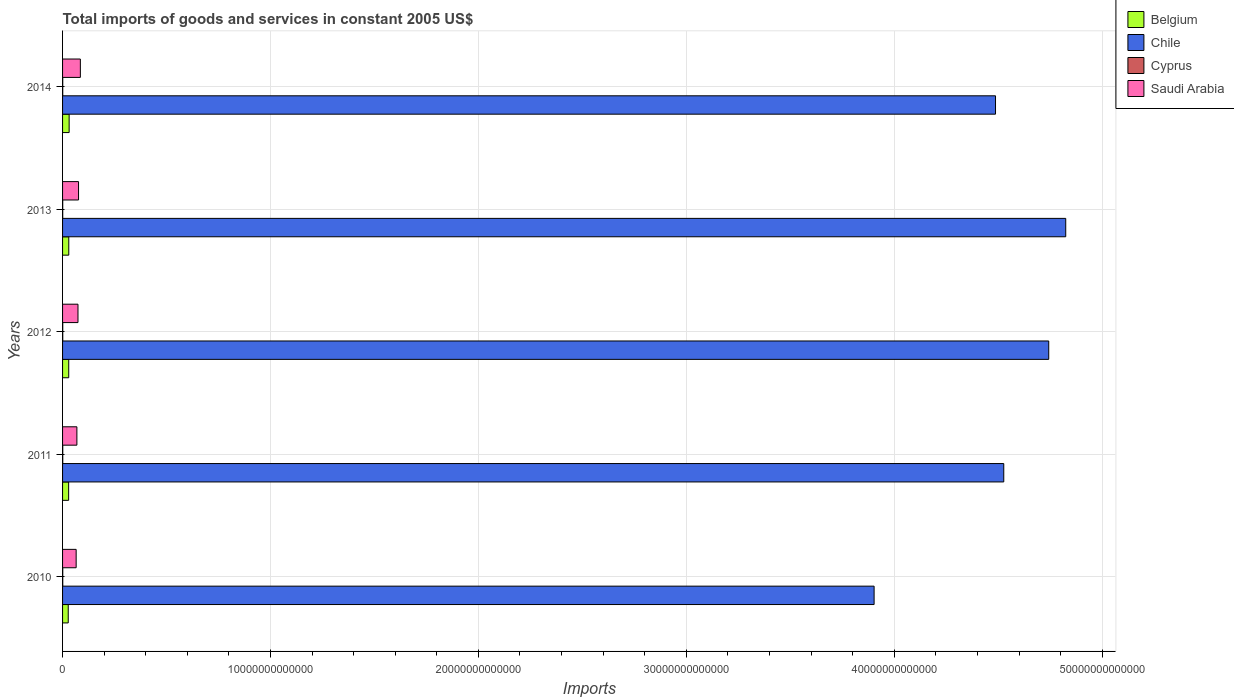How many groups of bars are there?
Make the answer very short. 5. Are the number of bars on each tick of the Y-axis equal?
Your answer should be compact. Yes. How many bars are there on the 5th tick from the bottom?
Make the answer very short. 4. What is the total imports of goods and services in Cyprus in 2012?
Ensure brevity in your answer.  8.72e+09. Across all years, what is the maximum total imports of goods and services in Cyprus?
Ensure brevity in your answer.  9.20e+09. Across all years, what is the minimum total imports of goods and services in Chile?
Keep it short and to the point. 3.90e+13. In which year was the total imports of goods and services in Saudi Arabia minimum?
Keep it short and to the point. 2010. What is the total total imports of goods and services in Saudi Arabia in the graph?
Your answer should be very brief. 3.71e+12. What is the difference between the total imports of goods and services in Cyprus in 2010 and that in 2014?
Offer a terse response. 1.06e+09. What is the difference between the total imports of goods and services in Chile in 2011 and the total imports of goods and services in Belgium in 2013?
Offer a terse response. 4.50e+13. What is the average total imports of goods and services in Saudi Arabia per year?
Offer a very short reply. 7.42e+11. In the year 2011, what is the difference between the total imports of goods and services in Cyprus and total imports of goods and services in Belgium?
Provide a succinct answer. -2.83e+11. What is the ratio of the total imports of goods and services in Belgium in 2011 to that in 2014?
Keep it short and to the point. 0.92. Is the total imports of goods and services in Chile in 2013 less than that in 2014?
Your response must be concise. No. Is the difference between the total imports of goods and services in Cyprus in 2011 and 2013 greater than the difference between the total imports of goods and services in Belgium in 2011 and 2013?
Provide a succinct answer. Yes. What is the difference between the highest and the second highest total imports of goods and services in Cyprus?
Offer a very short reply. 5.69e+07. What is the difference between the highest and the lowest total imports of goods and services in Belgium?
Offer a very short reply. 4.38e+1. Is the sum of the total imports of goods and services in Chile in 2011 and 2012 greater than the maximum total imports of goods and services in Cyprus across all years?
Provide a short and direct response. Yes. Is it the case that in every year, the sum of the total imports of goods and services in Cyprus and total imports of goods and services in Chile is greater than the sum of total imports of goods and services in Belgium and total imports of goods and services in Saudi Arabia?
Keep it short and to the point. Yes. Is it the case that in every year, the sum of the total imports of goods and services in Belgium and total imports of goods and services in Chile is greater than the total imports of goods and services in Cyprus?
Your response must be concise. Yes. How many bars are there?
Provide a short and direct response. 20. What is the difference between two consecutive major ticks on the X-axis?
Your answer should be very brief. 1.00e+13. Are the values on the major ticks of X-axis written in scientific E-notation?
Make the answer very short. No. Does the graph contain any zero values?
Ensure brevity in your answer.  No. Does the graph contain grids?
Offer a very short reply. Yes. What is the title of the graph?
Make the answer very short. Total imports of goods and services in constant 2005 US$. What is the label or title of the X-axis?
Keep it short and to the point. Imports. What is the Imports of Belgium in 2010?
Provide a succinct answer. 2.73e+11. What is the Imports of Chile in 2010?
Your answer should be compact. 3.90e+13. What is the Imports of Cyprus in 2010?
Your response must be concise. 9.20e+09. What is the Imports in Saudi Arabia in 2010?
Ensure brevity in your answer.  6.53e+11. What is the Imports of Belgium in 2011?
Make the answer very short. 2.92e+11. What is the Imports of Chile in 2011?
Your answer should be compact. 4.53e+13. What is the Imports in Cyprus in 2011?
Your answer should be very brief. 9.14e+09. What is the Imports in Saudi Arabia in 2011?
Keep it short and to the point. 6.89e+11. What is the Imports of Belgium in 2012?
Ensure brevity in your answer.  2.97e+11. What is the Imports of Chile in 2012?
Offer a terse response. 4.74e+13. What is the Imports in Cyprus in 2012?
Make the answer very short. 8.72e+09. What is the Imports of Saudi Arabia in 2012?
Your response must be concise. 7.42e+11. What is the Imports of Belgium in 2013?
Provide a succinct answer. 2.99e+11. What is the Imports in Chile in 2013?
Your answer should be compact. 4.82e+13. What is the Imports in Cyprus in 2013?
Your answer should be very brief. 7.54e+09. What is the Imports in Saudi Arabia in 2013?
Your response must be concise. 7.69e+11. What is the Imports of Belgium in 2014?
Your answer should be compact. 3.16e+11. What is the Imports of Chile in 2014?
Provide a short and direct response. 4.49e+13. What is the Imports of Cyprus in 2014?
Offer a terse response. 8.14e+09. What is the Imports of Saudi Arabia in 2014?
Ensure brevity in your answer.  8.56e+11. Across all years, what is the maximum Imports of Belgium?
Provide a succinct answer. 3.16e+11. Across all years, what is the maximum Imports of Chile?
Provide a succinct answer. 4.82e+13. Across all years, what is the maximum Imports of Cyprus?
Your answer should be compact. 9.20e+09. Across all years, what is the maximum Imports in Saudi Arabia?
Make the answer very short. 8.56e+11. Across all years, what is the minimum Imports of Belgium?
Keep it short and to the point. 2.73e+11. Across all years, what is the minimum Imports in Chile?
Your answer should be very brief. 3.90e+13. Across all years, what is the minimum Imports in Cyprus?
Ensure brevity in your answer.  7.54e+09. Across all years, what is the minimum Imports of Saudi Arabia?
Your answer should be compact. 6.53e+11. What is the total Imports in Belgium in the graph?
Offer a very short reply. 1.48e+12. What is the total Imports in Chile in the graph?
Your answer should be compact. 2.25e+14. What is the total Imports of Cyprus in the graph?
Offer a very short reply. 4.27e+1. What is the total Imports of Saudi Arabia in the graph?
Offer a terse response. 3.71e+12. What is the difference between the Imports in Belgium in 2010 and that in 2011?
Make the answer very short. -1.99e+1. What is the difference between the Imports in Chile in 2010 and that in 2011?
Your response must be concise. -6.24e+12. What is the difference between the Imports of Cyprus in 2010 and that in 2011?
Your response must be concise. 5.69e+07. What is the difference between the Imports in Saudi Arabia in 2010 and that in 2011?
Keep it short and to the point. -3.57e+1. What is the difference between the Imports of Belgium in 2010 and that in 2012?
Give a very brief answer. -2.40e+1. What is the difference between the Imports in Chile in 2010 and that in 2012?
Keep it short and to the point. -8.40e+12. What is the difference between the Imports in Cyprus in 2010 and that in 2012?
Provide a succinct answer. 4.77e+08. What is the difference between the Imports of Saudi Arabia in 2010 and that in 2012?
Provide a short and direct response. -8.85e+1. What is the difference between the Imports of Belgium in 2010 and that in 2013?
Your answer should be compact. -2.62e+1. What is the difference between the Imports of Chile in 2010 and that in 2013?
Keep it short and to the point. -9.22e+12. What is the difference between the Imports of Cyprus in 2010 and that in 2013?
Your answer should be very brief. 1.66e+09. What is the difference between the Imports in Saudi Arabia in 2010 and that in 2013?
Provide a succinct answer. -1.16e+11. What is the difference between the Imports in Belgium in 2010 and that in 2014?
Keep it short and to the point. -4.38e+1. What is the difference between the Imports of Chile in 2010 and that in 2014?
Provide a short and direct response. -5.84e+12. What is the difference between the Imports of Cyprus in 2010 and that in 2014?
Keep it short and to the point. 1.06e+09. What is the difference between the Imports of Saudi Arabia in 2010 and that in 2014?
Your answer should be compact. -2.03e+11. What is the difference between the Imports of Belgium in 2011 and that in 2012?
Make the answer very short. -4.03e+09. What is the difference between the Imports in Chile in 2011 and that in 2012?
Keep it short and to the point. -2.16e+12. What is the difference between the Imports of Cyprus in 2011 and that in 2012?
Provide a succinct answer. 4.20e+08. What is the difference between the Imports of Saudi Arabia in 2011 and that in 2012?
Keep it short and to the point. -5.28e+1. What is the difference between the Imports in Belgium in 2011 and that in 2013?
Give a very brief answer. -6.32e+09. What is the difference between the Imports in Chile in 2011 and that in 2013?
Offer a very short reply. -2.98e+12. What is the difference between the Imports in Cyprus in 2011 and that in 2013?
Your response must be concise. 1.61e+09. What is the difference between the Imports in Saudi Arabia in 2011 and that in 2013?
Make the answer very short. -7.99e+1. What is the difference between the Imports of Belgium in 2011 and that in 2014?
Ensure brevity in your answer.  -2.39e+1. What is the difference between the Imports of Chile in 2011 and that in 2014?
Your response must be concise. 3.96e+11. What is the difference between the Imports in Cyprus in 2011 and that in 2014?
Offer a terse response. 9.99e+08. What is the difference between the Imports of Saudi Arabia in 2011 and that in 2014?
Offer a terse response. -1.67e+11. What is the difference between the Imports in Belgium in 2012 and that in 2013?
Give a very brief answer. -2.29e+09. What is the difference between the Imports in Chile in 2012 and that in 2013?
Make the answer very short. -8.18e+11. What is the difference between the Imports in Cyprus in 2012 and that in 2013?
Offer a very short reply. 1.19e+09. What is the difference between the Imports in Saudi Arabia in 2012 and that in 2013?
Keep it short and to the point. -2.71e+1. What is the difference between the Imports in Belgium in 2012 and that in 2014?
Make the answer very short. -1.99e+1. What is the difference between the Imports of Chile in 2012 and that in 2014?
Give a very brief answer. 2.56e+12. What is the difference between the Imports of Cyprus in 2012 and that in 2014?
Provide a succinct answer. 5.79e+08. What is the difference between the Imports of Saudi Arabia in 2012 and that in 2014?
Provide a short and direct response. -1.14e+11. What is the difference between the Imports in Belgium in 2013 and that in 2014?
Provide a succinct answer. -1.76e+1. What is the difference between the Imports of Chile in 2013 and that in 2014?
Give a very brief answer. 3.38e+12. What is the difference between the Imports of Cyprus in 2013 and that in 2014?
Provide a short and direct response. -6.08e+08. What is the difference between the Imports of Saudi Arabia in 2013 and that in 2014?
Offer a terse response. -8.70e+1. What is the difference between the Imports in Belgium in 2010 and the Imports in Chile in 2011?
Keep it short and to the point. -4.50e+13. What is the difference between the Imports in Belgium in 2010 and the Imports in Cyprus in 2011?
Offer a terse response. 2.63e+11. What is the difference between the Imports of Belgium in 2010 and the Imports of Saudi Arabia in 2011?
Offer a terse response. -4.16e+11. What is the difference between the Imports in Chile in 2010 and the Imports in Cyprus in 2011?
Provide a succinct answer. 3.90e+13. What is the difference between the Imports of Chile in 2010 and the Imports of Saudi Arabia in 2011?
Your answer should be compact. 3.83e+13. What is the difference between the Imports in Cyprus in 2010 and the Imports in Saudi Arabia in 2011?
Give a very brief answer. -6.80e+11. What is the difference between the Imports in Belgium in 2010 and the Imports in Chile in 2012?
Ensure brevity in your answer.  -4.72e+13. What is the difference between the Imports in Belgium in 2010 and the Imports in Cyprus in 2012?
Your answer should be compact. 2.64e+11. What is the difference between the Imports in Belgium in 2010 and the Imports in Saudi Arabia in 2012?
Your response must be concise. -4.69e+11. What is the difference between the Imports in Chile in 2010 and the Imports in Cyprus in 2012?
Your answer should be very brief. 3.90e+13. What is the difference between the Imports in Chile in 2010 and the Imports in Saudi Arabia in 2012?
Keep it short and to the point. 3.83e+13. What is the difference between the Imports in Cyprus in 2010 and the Imports in Saudi Arabia in 2012?
Provide a short and direct response. -7.33e+11. What is the difference between the Imports of Belgium in 2010 and the Imports of Chile in 2013?
Your answer should be very brief. -4.80e+13. What is the difference between the Imports in Belgium in 2010 and the Imports in Cyprus in 2013?
Provide a short and direct response. 2.65e+11. What is the difference between the Imports in Belgium in 2010 and the Imports in Saudi Arabia in 2013?
Offer a very short reply. -4.96e+11. What is the difference between the Imports in Chile in 2010 and the Imports in Cyprus in 2013?
Offer a very short reply. 3.90e+13. What is the difference between the Imports in Chile in 2010 and the Imports in Saudi Arabia in 2013?
Provide a short and direct response. 3.83e+13. What is the difference between the Imports in Cyprus in 2010 and the Imports in Saudi Arabia in 2013?
Your response must be concise. -7.60e+11. What is the difference between the Imports of Belgium in 2010 and the Imports of Chile in 2014?
Your answer should be very brief. -4.46e+13. What is the difference between the Imports of Belgium in 2010 and the Imports of Cyprus in 2014?
Keep it short and to the point. 2.64e+11. What is the difference between the Imports of Belgium in 2010 and the Imports of Saudi Arabia in 2014?
Make the answer very short. -5.83e+11. What is the difference between the Imports of Chile in 2010 and the Imports of Cyprus in 2014?
Provide a short and direct response. 3.90e+13. What is the difference between the Imports of Chile in 2010 and the Imports of Saudi Arabia in 2014?
Your answer should be compact. 3.82e+13. What is the difference between the Imports of Cyprus in 2010 and the Imports of Saudi Arabia in 2014?
Your answer should be compact. -8.47e+11. What is the difference between the Imports in Belgium in 2011 and the Imports in Chile in 2012?
Your answer should be compact. -4.71e+13. What is the difference between the Imports in Belgium in 2011 and the Imports in Cyprus in 2012?
Give a very brief answer. 2.84e+11. What is the difference between the Imports of Belgium in 2011 and the Imports of Saudi Arabia in 2012?
Make the answer very short. -4.49e+11. What is the difference between the Imports of Chile in 2011 and the Imports of Cyprus in 2012?
Provide a short and direct response. 4.53e+13. What is the difference between the Imports of Chile in 2011 and the Imports of Saudi Arabia in 2012?
Provide a succinct answer. 4.45e+13. What is the difference between the Imports of Cyprus in 2011 and the Imports of Saudi Arabia in 2012?
Provide a succinct answer. -7.33e+11. What is the difference between the Imports of Belgium in 2011 and the Imports of Chile in 2013?
Offer a terse response. -4.80e+13. What is the difference between the Imports in Belgium in 2011 and the Imports in Cyprus in 2013?
Ensure brevity in your answer.  2.85e+11. What is the difference between the Imports in Belgium in 2011 and the Imports in Saudi Arabia in 2013?
Offer a very short reply. -4.76e+11. What is the difference between the Imports in Chile in 2011 and the Imports in Cyprus in 2013?
Your answer should be compact. 4.53e+13. What is the difference between the Imports in Chile in 2011 and the Imports in Saudi Arabia in 2013?
Make the answer very short. 4.45e+13. What is the difference between the Imports in Cyprus in 2011 and the Imports in Saudi Arabia in 2013?
Your response must be concise. -7.60e+11. What is the difference between the Imports in Belgium in 2011 and the Imports in Chile in 2014?
Your response must be concise. -4.46e+13. What is the difference between the Imports of Belgium in 2011 and the Imports of Cyprus in 2014?
Your answer should be compact. 2.84e+11. What is the difference between the Imports of Belgium in 2011 and the Imports of Saudi Arabia in 2014?
Give a very brief answer. -5.63e+11. What is the difference between the Imports of Chile in 2011 and the Imports of Cyprus in 2014?
Your answer should be compact. 4.53e+13. What is the difference between the Imports of Chile in 2011 and the Imports of Saudi Arabia in 2014?
Provide a short and direct response. 4.44e+13. What is the difference between the Imports of Cyprus in 2011 and the Imports of Saudi Arabia in 2014?
Ensure brevity in your answer.  -8.47e+11. What is the difference between the Imports in Belgium in 2012 and the Imports in Chile in 2013?
Make the answer very short. -4.80e+13. What is the difference between the Imports in Belgium in 2012 and the Imports in Cyprus in 2013?
Your answer should be very brief. 2.89e+11. What is the difference between the Imports in Belgium in 2012 and the Imports in Saudi Arabia in 2013?
Your answer should be compact. -4.72e+11. What is the difference between the Imports of Chile in 2012 and the Imports of Cyprus in 2013?
Make the answer very short. 4.74e+13. What is the difference between the Imports in Chile in 2012 and the Imports in Saudi Arabia in 2013?
Your answer should be compact. 4.67e+13. What is the difference between the Imports in Cyprus in 2012 and the Imports in Saudi Arabia in 2013?
Ensure brevity in your answer.  -7.60e+11. What is the difference between the Imports in Belgium in 2012 and the Imports in Chile in 2014?
Provide a short and direct response. -4.46e+13. What is the difference between the Imports in Belgium in 2012 and the Imports in Cyprus in 2014?
Make the answer very short. 2.88e+11. What is the difference between the Imports of Belgium in 2012 and the Imports of Saudi Arabia in 2014?
Give a very brief answer. -5.59e+11. What is the difference between the Imports of Chile in 2012 and the Imports of Cyprus in 2014?
Make the answer very short. 4.74e+13. What is the difference between the Imports in Chile in 2012 and the Imports in Saudi Arabia in 2014?
Provide a short and direct response. 4.66e+13. What is the difference between the Imports of Cyprus in 2012 and the Imports of Saudi Arabia in 2014?
Offer a very short reply. -8.47e+11. What is the difference between the Imports in Belgium in 2013 and the Imports in Chile in 2014?
Offer a terse response. -4.46e+13. What is the difference between the Imports of Belgium in 2013 and the Imports of Cyprus in 2014?
Offer a very short reply. 2.91e+11. What is the difference between the Imports of Belgium in 2013 and the Imports of Saudi Arabia in 2014?
Offer a very short reply. -5.57e+11. What is the difference between the Imports of Chile in 2013 and the Imports of Cyprus in 2014?
Give a very brief answer. 4.82e+13. What is the difference between the Imports of Chile in 2013 and the Imports of Saudi Arabia in 2014?
Offer a terse response. 4.74e+13. What is the difference between the Imports of Cyprus in 2013 and the Imports of Saudi Arabia in 2014?
Keep it short and to the point. -8.48e+11. What is the average Imports of Belgium per year?
Offer a very short reply. 2.95e+11. What is the average Imports of Chile per year?
Give a very brief answer. 4.50e+13. What is the average Imports of Cyprus per year?
Give a very brief answer. 8.55e+09. What is the average Imports in Saudi Arabia per year?
Provide a short and direct response. 7.42e+11. In the year 2010, what is the difference between the Imports in Belgium and Imports in Chile?
Your answer should be compact. -3.88e+13. In the year 2010, what is the difference between the Imports in Belgium and Imports in Cyprus?
Provide a short and direct response. 2.63e+11. In the year 2010, what is the difference between the Imports in Belgium and Imports in Saudi Arabia?
Ensure brevity in your answer.  -3.81e+11. In the year 2010, what is the difference between the Imports in Chile and Imports in Cyprus?
Ensure brevity in your answer.  3.90e+13. In the year 2010, what is the difference between the Imports in Chile and Imports in Saudi Arabia?
Provide a short and direct response. 3.84e+13. In the year 2010, what is the difference between the Imports of Cyprus and Imports of Saudi Arabia?
Keep it short and to the point. -6.44e+11. In the year 2011, what is the difference between the Imports in Belgium and Imports in Chile?
Offer a terse response. -4.50e+13. In the year 2011, what is the difference between the Imports in Belgium and Imports in Cyprus?
Keep it short and to the point. 2.83e+11. In the year 2011, what is the difference between the Imports of Belgium and Imports of Saudi Arabia?
Provide a succinct answer. -3.97e+11. In the year 2011, what is the difference between the Imports of Chile and Imports of Cyprus?
Your answer should be compact. 4.53e+13. In the year 2011, what is the difference between the Imports in Chile and Imports in Saudi Arabia?
Your response must be concise. 4.46e+13. In the year 2011, what is the difference between the Imports in Cyprus and Imports in Saudi Arabia?
Offer a terse response. -6.80e+11. In the year 2012, what is the difference between the Imports in Belgium and Imports in Chile?
Provide a short and direct response. -4.71e+13. In the year 2012, what is the difference between the Imports of Belgium and Imports of Cyprus?
Provide a short and direct response. 2.88e+11. In the year 2012, what is the difference between the Imports of Belgium and Imports of Saudi Arabia?
Keep it short and to the point. -4.45e+11. In the year 2012, what is the difference between the Imports of Chile and Imports of Cyprus?
Your answer should be very brief. 4.74e+13. In the year 2012, what is the difference between the Imports in Chile and Imports in Saudi Arabia?
Give a very brief answer. 4.67e+13. In the year 2012, what is the difference between the Imports of Cyprus and Imports of Saudi Arabia?
Keep it short and to the point. -7.33e+11. In the year 2013, what is the difference between the Imports in Belgium and Imports in Chile?
Provide a short and direct response. -4.79e+13. In the year 2013, what is the difference between the Imports in Belgium and Imports in Cyprus?
Make the answer very short. 2.91e+11. In the year 2013, what is the difference between the Imports of Belgium and Imports of Saudi Arabia?
Offer a very short reply. -4.70e+11. In the year 2013, what is the difference between the Imports of Chile and Imports of Cyprus?
Ensure brevity in your answer.  4.82e+13. In the year 2013, what is the difference between the Imports in Chile and Imports in Saudi Arabia?
Your response must be concise. 4.75e+13. In the year 2013, what is the difference between the Imports in Cyprus and Imports in Saudi Arabia?
Provide a succinct answer. -7.61e+11. In the year 2014, what is the difference between the Imports of Belgium and Imports of Chile?
Make the answer very short. -4.46e+13. In the year 2014, what is the difference between the Imports in Belgium and Imports in Cyprus?
Give a very brief answer. 3.08e+11. In the year 2014, what is the difference between the Imports in Belgium and Imports in Saudi Arabia?
Make the answer very short. -5.39e+11. In the year 2014, what is the difference between the Imports in Chile and Imports in Cyprus?
Your answer should be compact. 4.49e+13. In the year 2014, what is the difference between the Imports of Chile and Imports of Saudi Arabia?
Your answer should be very brief. 4.40e+13. In the year 2014, what is the difference between the Imports in Cyprus and Imports in Saudi Arabia?
Keep it short and to the point. -8.48e+11. What is the ratio of the Imports of Belgium in 2010 to that in 2011?
Make the answer very short. 0.93. What is the ratio of the Imports in Chile in 2010 to that in 2011?
Provide a succinct answer. 0.86. What is the ratio of the Imports in Saudi Arabia in 2010 to that in 2011?
Offer a terse response. 0.95. What is the ratio of the Imports in Belgium in 2010 to that in 2012?
Make the answer very short. 0.92. What is the ratio of the Imports in Chile in 2010 to that in 2012?
Keep it short and to the point. 0.82. What is the ratio of the Imports of Cyprus in 2010 to that in 2012?
Provide a succinct answer. 1.05. What is the ratio of the Imports of Saudi Arabia in 2010 to that in 2012?
Your answer should be very brief. 0.88. What is the ratio of the Imports in Belgium in 2010 to that in 2013?
Offer a very short reply. 0.91. What is the ratio of the Imports of Chile in 2010 to that in 2013?
Offer a terse response. 0.81. What is the ratio of the Imports of Cyprus in 2010 to that in 2013?
Provide a succinct answer. 1.22. What is the ratio of the Imports in Saudi Arabia in 2010 to that in 2013?
Ensure brevity in your answer.  0.85. What is the ratio of the Imports in Belgium in 2010 to that in 2014?
Make the answer very short. 0.86. What is the ratio of the Imports of Chile in 2010 to that in 2014?
Your answer should be very brief. 0.87. What is the ratio of the Imports in Cyprus in 2010 to that in 2014?
Offer a terse response. 1.13. What is the ratio of the Imports in Saudi Arabia in 2010 to that in 2014?
Provide a short and direct response. 0.76. What is the ratio of the Imports of Belgium in 2011 to that in 2012?
Offer a terse response. 0.99. What is the ratio of the Imports of Chile in 2011 to that in 2012?
Keep it short and to the point. 0.95. What is the ratio of the Imports of Cyprus in 2011 to that in 2012?
Your answer should be compact. 1.05. What is the ratio of the Imports in Saudi Arabia in 2011 to that in 2012?
Give a very brief answer. 0.93. What is the ratio of the Imports of Belgium in 2011 to that in 2013?
Your answer should be very brief. 0.98. What is the ratio of the Imports of Chile in 2011 to that in 2013?
Provide a succinct answer. 0.94. What is the ratio of the Imports of Cyprus in 2011 to that in 2013?
Ensure brevity in your answer.  1.21. What is the ratio of the Imports of Saudi Arabia in 2011 to that in 2013?
Offer a terse response. 0.9. What is the ratio of the Imports in Belgium in 2011 to that in 2014?
Provide a succinct answer. 0.92. What is the ratio of the Imports of Chile in 2011 to that in 2014?
Provide a short and direct response. 1.01. What is the ratio of the Imports in Cyprus in 2011 to that in 2014?
Your answer should be compact. 1.12. What is the ratio of the Imports in Saudi Arabia in 2011 to that in 2014?
Keep it short and to the point. 0.81. What is the ratio of the Imports of Belgium in 2012 to that in 2013?
Offer a very short reply. 0.99. What is the ratio of the Imports of Chile in 2012 to that in 2013?
Offer a terse response. 0.98. What is the ratio of the Imports in Cyprus in 2012 to that in 2013?
Your answer should be very brief. 1.16. What is the ratio of the Imports of Saudi Arabia in 2012 to that in 2013?
Provide a succinct answer. 0.96. What is the ratio of the Imports in Belgium in 2012 to that in 2014?
Your answer should be very brief. 0.94. What is the ratio of the Imports of Chile in 2012 to that in 2014?
Keep it short and to the point. 1.06. What is the ratio of the Imports in Cyprus in 2012 to that in 2014?
Offer a terse response. 1.07. What is the ratio of the Imports in Saudi Arabia in 2012 to that in 2014?
Offer a terse response. 0.87. What is the ratio of the Imports in Chile in 2013 to that in 2014?
Offer a very short reply. 1.08. What is the ratio of the Imports of Cyprus in 2013 to that in 2014?
Offer a terse response. 0.93. What is the ratio of the Imports in Saudi Arabia in 2013 to that in 2014?
Give a very brief answer. 0.9. What is the difference between the highest and the second highest Imports in Belgium?
Make the answer very short. 1.76e+1. What is the difference between the highest and the second highest Imports of Chile?
Offer a terse response. 8.18e+11. What is the difference between the highest and the second highest Imports of Cyprus?
Your answer should be compact. 5.69e+07. What is the difference between the highest and the second highest Imports of Saudi Arabia?
Your answer should be very brief. 8.70e+1. What is the difference between the highest and the lowest Imports in Belgium?
Make the answer very short. 4.38e+1. What is the difference between the highest and the lowest Imports of Chile?
Your answer should be very brief. 9.22e+12. What is the difference between the highest and the lowest Imports in Cyprus?
Your answer should be compact. 1.66e+09. What is the difference between the highest and the lowest Imports in Saudi Arabia?
Provide a short and direct response. 2.03e+11. 